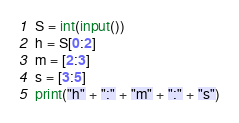Convert code to text. <code><loc_0><loc_0><loc_500><loc_500><_Python_>S = int(input())
h = S[0:2]
m = [2:3]
s = [3:5]
print("h" + ":" + "m" + ":" + "s")</code> 